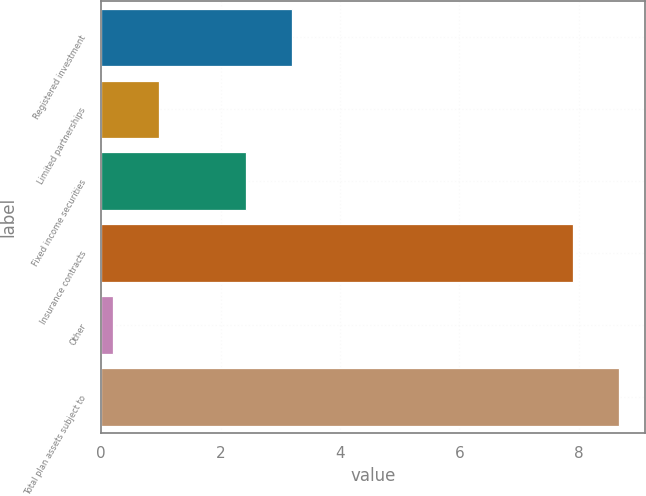Convert chart to OTSL. <chart><loc_0><loc_0><loc_500><loc_500><bar_chart><fcel>Registered investment<fcel>Limited partnerships<fcel>Fixed income securities<fcel>Insurance contracts<fcel>Other<fcel>Total plan assets subject to<nl><fcel>3.19<fcel>0.96<fcel>2.42<fcel>7.9<fcel>0.19<fcel>8.67<nl></chart> 